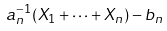<formula> <loc_0><loc_0><loc_500><loc_500>a _ { n } ^ { - 1 } ( X _ { 1 } + \dots + X _ { n } ) - b _ { n }</formula> 